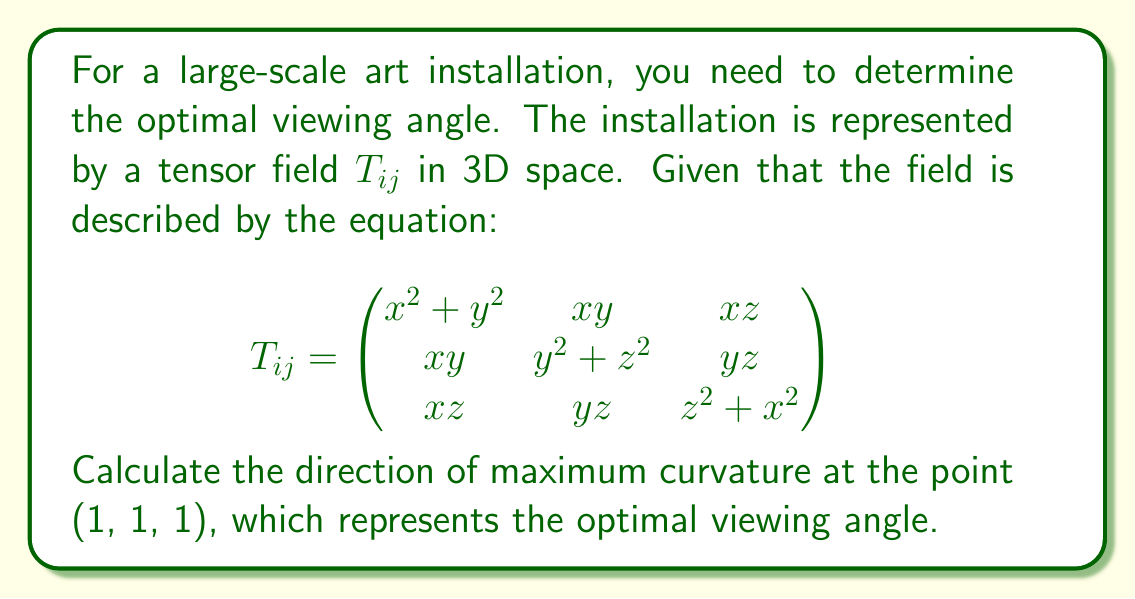Give your solution to this math problem. To find the direction of maximum curvature, we need to follow these steps:

1) First, we need to calculate the gradient of the tensor field at the point (1, 1, 1). The gradient is given by:

   $$\nabla T_{ij} = \left(\frac{\partial T_{ij}}{\partial x}, \frac{\partial T_{ij}}{\partial y}, \frac{\partial T_{ij}}{\partial z}\right)$$

2) Calculating the partial derivatives:

   $$\frac{\partial T_{ij}}{\partial x} = \begin{pmatrix}
   2x & y & z \\
   y & 0 & 0 \\
   z & 0 & 2x
   \end{pmatrix}$$

   $$\frac{\partial T_{ij}}{\partial y} = \begin{pmatrix}
   2y & x & 0 \\
   x & 2y & z \\
   0 & z & 0
   \end{pmatrix}$$

   $$\frac{\partial T_{ij}}{\partial z} = \begin{pmatrix}
   0 & 0 & x \\
   0 & 2z & y \\
   x & y & 2z
   \end{pmatrix}$$

3) Evaluating at the point (1, 1, 1):

   $$\nabla T_{ij}|(1,1,1) = \left(\begin{pmatrix}
   2 & 1 & 1 \\
   1 & 0 & 0 \\
   1 & 0 & 2
   \end{pmatrix}, \begin{pmatrix}
   2 & 1 & 0 \\
   1 & 2 & 1 \\
   0 & 1 & 0
   \end{pmatrix}, \begin{pmatrix}
   0 & 0 & 1 \\
   0 & 2 & 1 \\
   1 & 1 & 2
   \end{pmatrix}\right)$$

4) The direction of maximum curvature is given by the eigenvector corresponding to the largest eigenvalue of the sum of these matrices:

   $$M = \begin{pmatrix}
   4 & 2 & 2 \\
   2 & 4 & 2 \\
   2 & 2 & 4
   \end{pmatrix}$$

5) The characteristic equation for M is:

   $$det(M - \lambda I) = -\lambda^3 + 12\lambda^2 - 36\lambda + 24 = 0$$

6) Solving this equation, we get eigenvalues: $\lambda_1 = 2$, $\lambda_2 = 2$, $\lambda_3 = 8$

7) The eigenvector corresponding to $\lambda_3 = 8$ (the largest eigenvalue) is the direction of maximum curvature. We can find this by solving:

   $$(M - 8I)v = 0$$

8) Solving this system of equations, we get:

   $$v = k(1, 1, 1)$$

   where k is any non-zero constant.

Thus, the direction of maximum curvature, and therefore the optimal viewing angle, is along the vector (1, 1, 1).
Answer: $(1, 1, 1)$ 